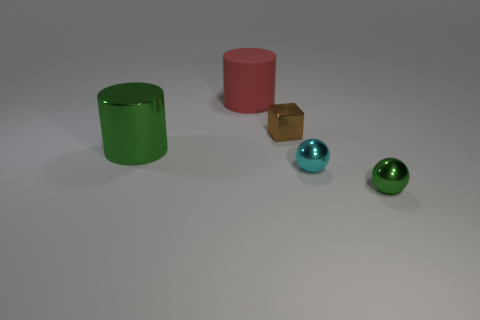Add 5 large green shiny cylinders. How many objects exist? 10 Subtract all balls. How many objects are left? 3 Subtract all big red objects. Subtract all big green metallic cylinders. How many objects are left? 3 Add 5 big green things. How many big green things are left? 6 Add 2 rubber cylinders. How many rubber cylinders exist? 3 Subtract 0 blue blocks. How many objects are left? 5 